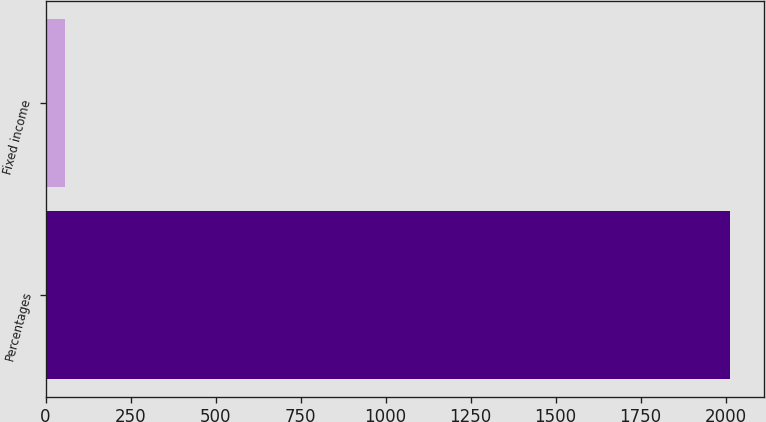<chart> <loc_0><loc_0><loc_500><loc_500><bar_chart><fcel>Percentages<fcel>Fixed income<nl><fcel>2012<fcel>56<nl></chart> 